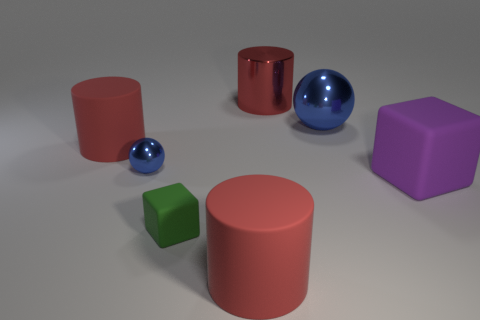There is a small ball that is the same color as the large metallic sphere; what is its material?
Your answer should be compact. Metal. Are there any shiny things that have the same color as the large metallic sphere?
Give a very brief answer. Yes. Are there fewer big things to the left of the small blue metal object than big brown shiny cubes?
Offer a very short reply. No. There is a red metallic cylinder behind the green matte thing; is it the same size as the big sphere?
Ensure brevity in your answer.  Yes. How many objects are both to the right of the tiny metallic object and behind the tiny block?
Your response must be concise. 3. There is a blue metallic object that is to the right of the blue object that is on the left side of the large red shiny object; how big is it?
Give a very brief answer. Large. Is the number of blue metallic balls that are behind the large metal ball less than the number of objects to the right of the tiny green block?
Your answer should be compact. Yes. There is a small thing behind the green block; is its color the same as the large metallic sphere in front of the big red metallic cylinder?
Provide a short and direct response. Yes. What is the material of the red thing that is both to the right of the small blue shiny thing and behind the green thing?
Provide a short and direct response. Metal. Are any large yellow metallic balls visible?
Make the answer very short. No. 